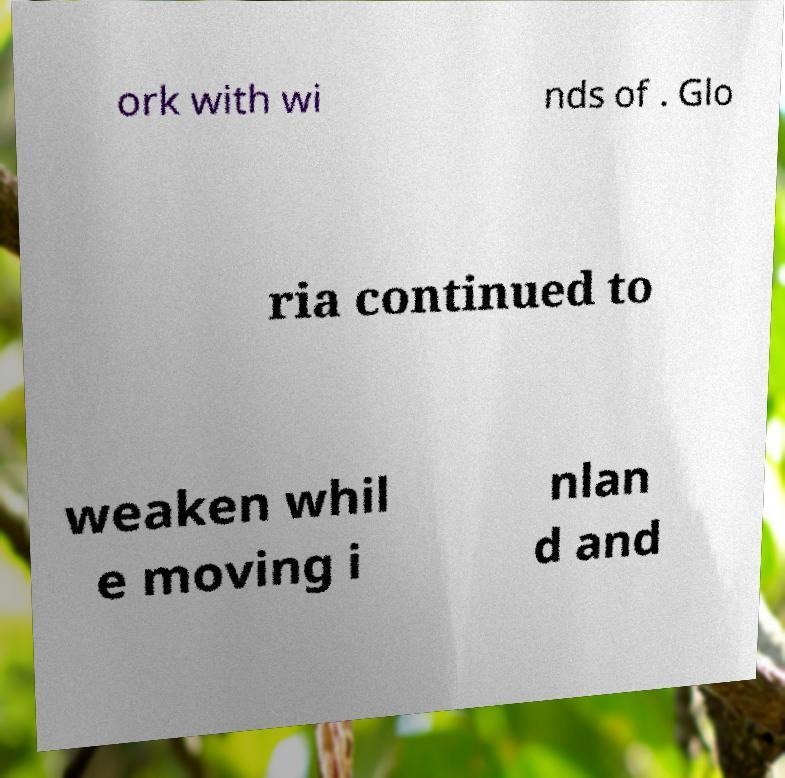Can you read and provide the text displayed in the image?This photo seems to have some interesting text. Can you extract and type it out for me? ork with wi nds of . Glo ria continued to weaken whil e moving i nlan d and 